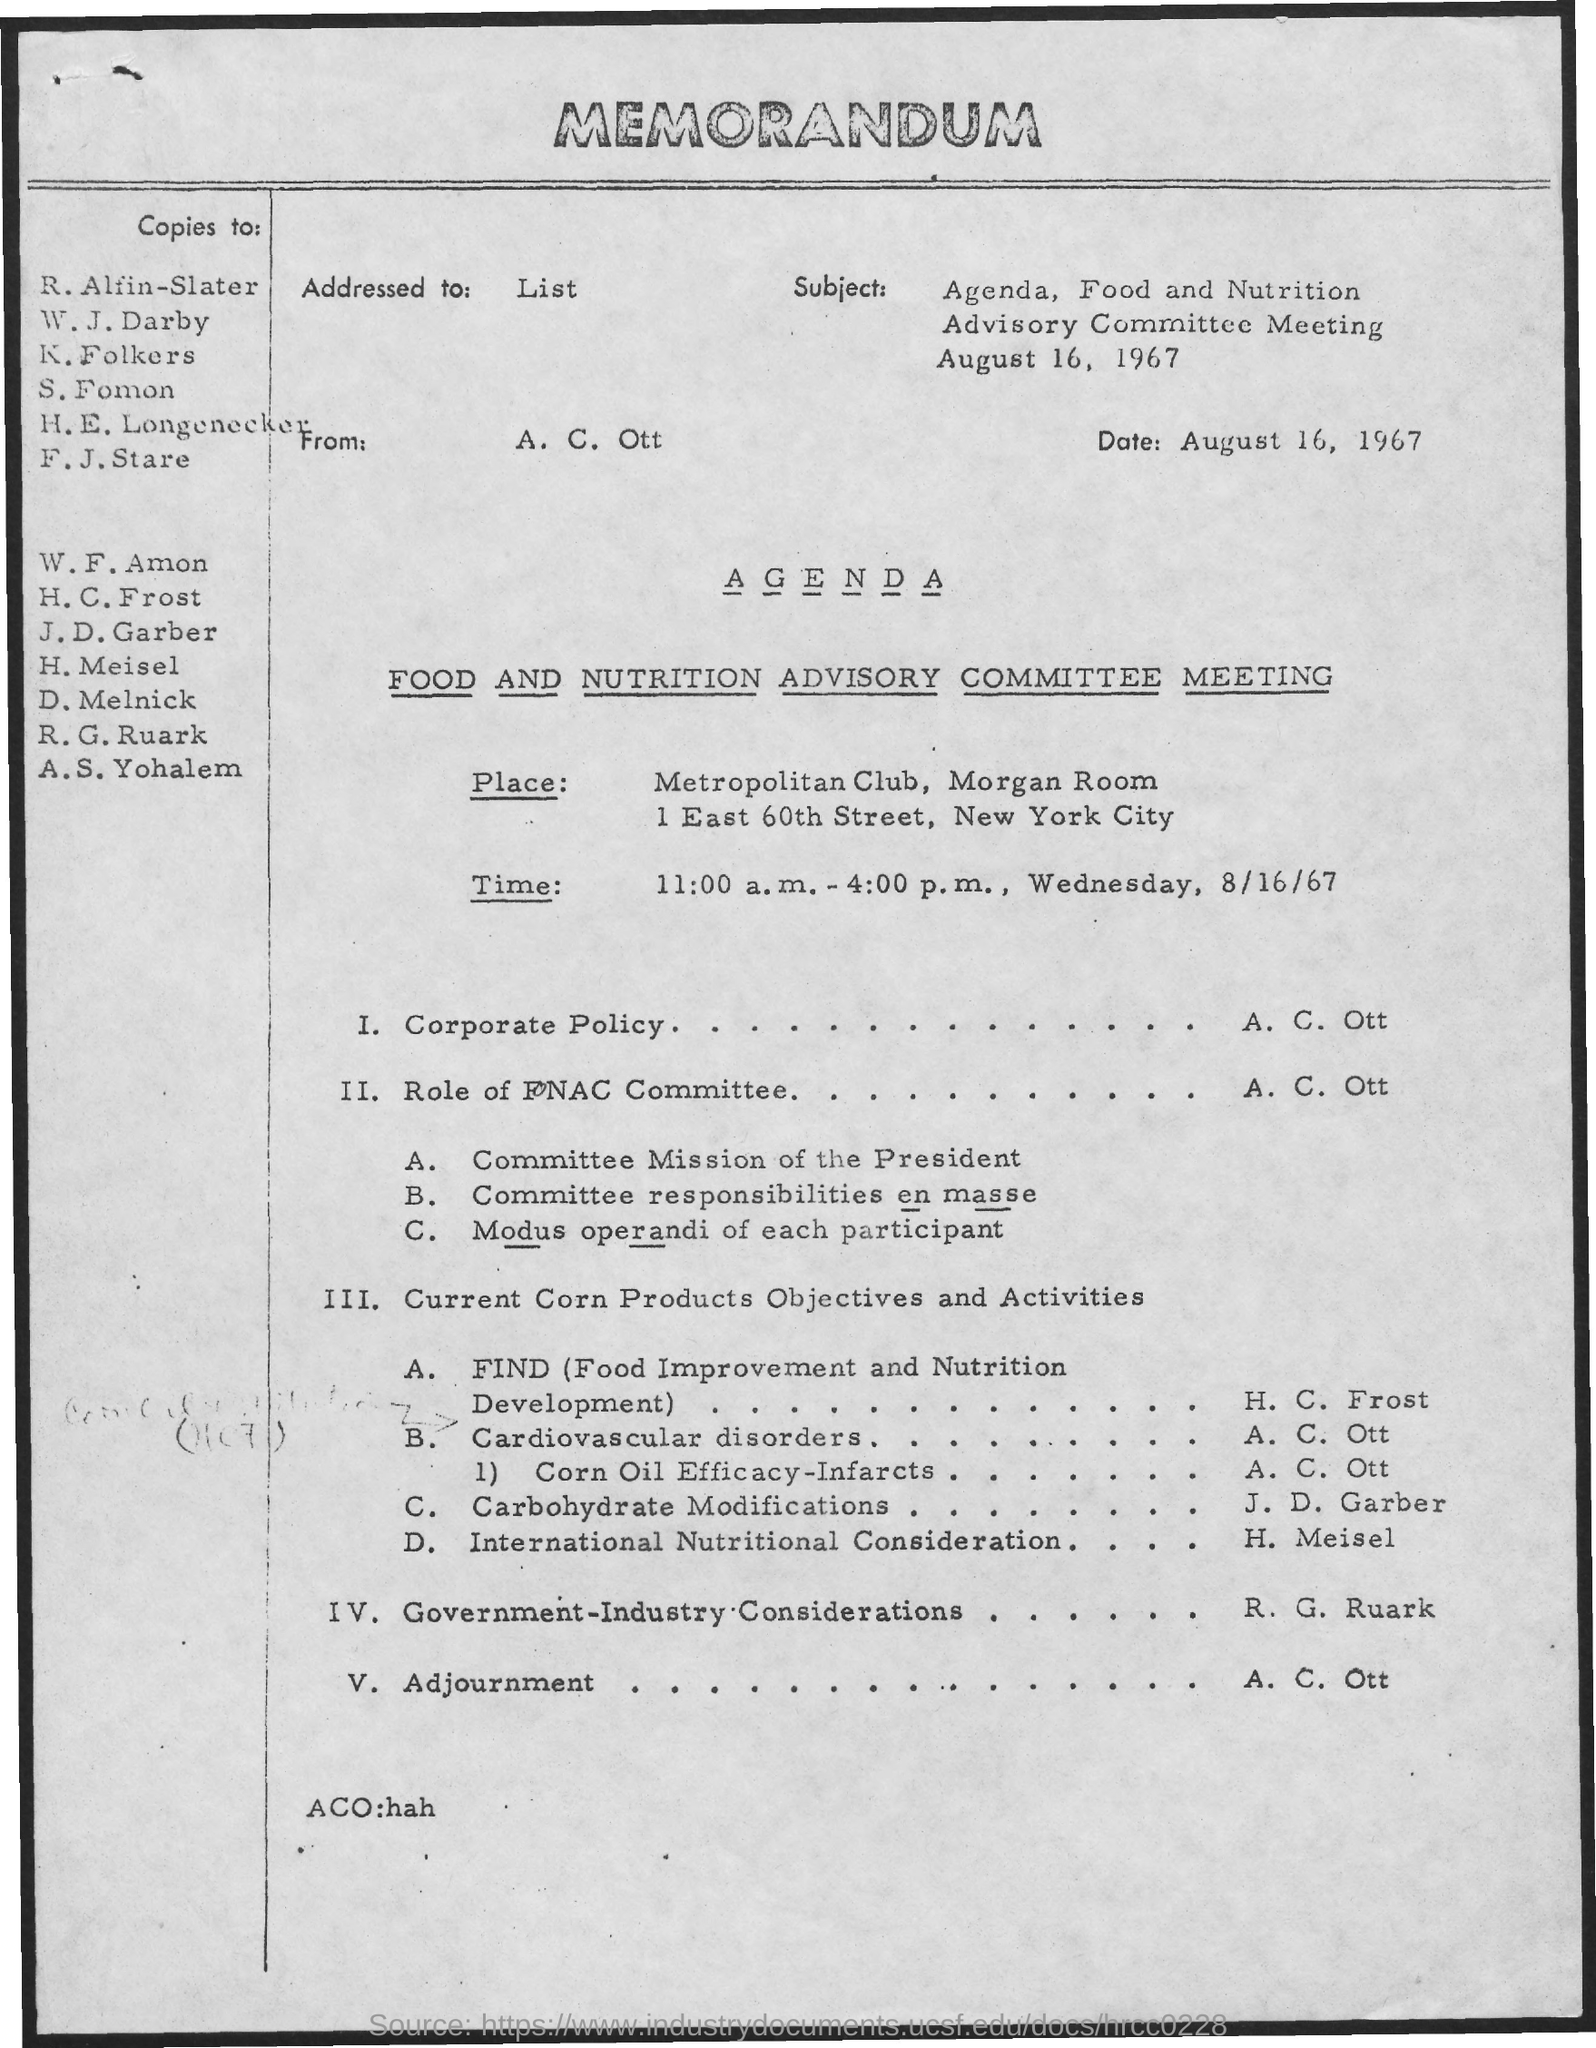What is the date mentioned in the given memorandum ?
Your response must be concise. August 16, 1967. What is the name of the meeting mentioned in the given agenda ?
Ensure brevity in your answer.  Food and nutrition advisory committee meeting. What is the venue for the meeing?
Give a very brief answer. Metropolitan club, morgan room. What is the scheduled time for the given meeting ?
Keep it short and to the point. 11:00 a.m. - 4:00 p.m. , wednesday, 8/16/67. What is the full form of find as mentioned in the given agenda ?
Your answer should be very brief. Food Improvement and Nutrition Development. What is the subject mentioned in the given memorandum ?
Give a very brief answer. Agenda, food and nutrition advisory committee meeting August 16, 1967. 